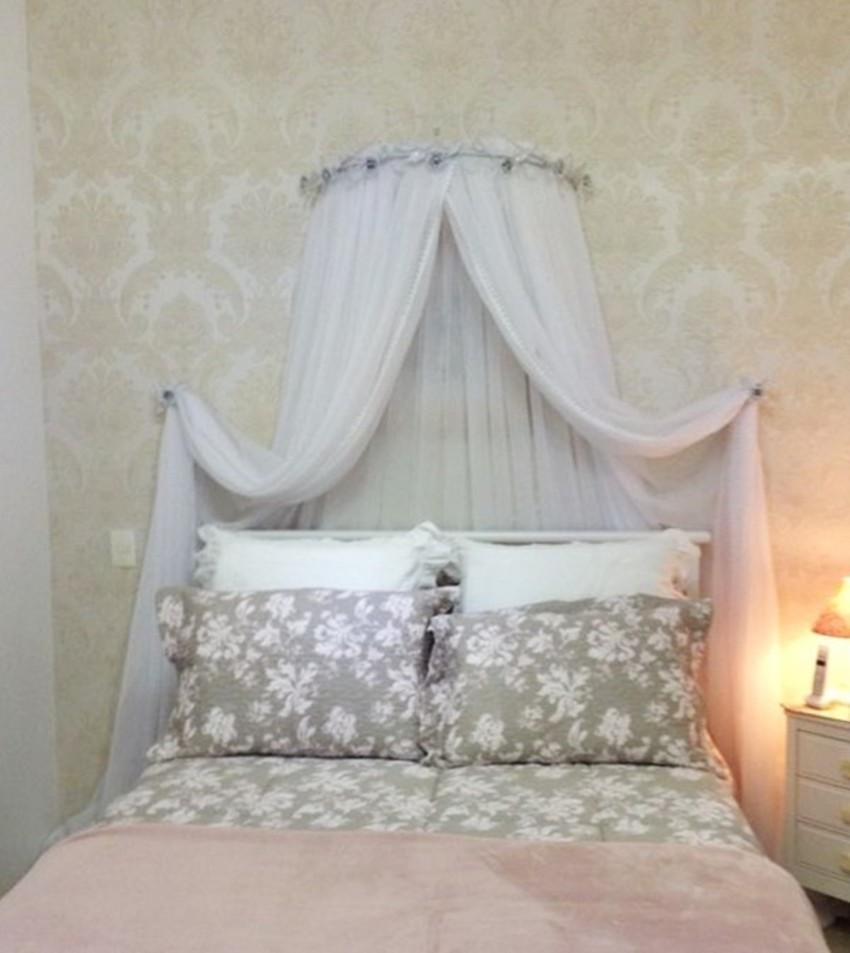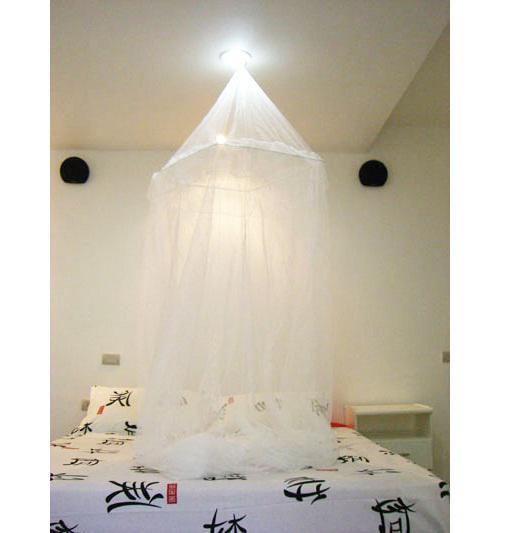The first image is the image on the left, the second image is the image on the right. For the images displayed, is the sentence "There are two white canopies; one hanging from the ceiling and the other mounted on the back wall." factually correct? Answer yes or no. Yes. The first image is the image on the left, the second image is the image on the right. Given the left and right images, does the statement "Exactly one canopy is attached to the ceiling." hold true? Answer yes or no. Yes. 